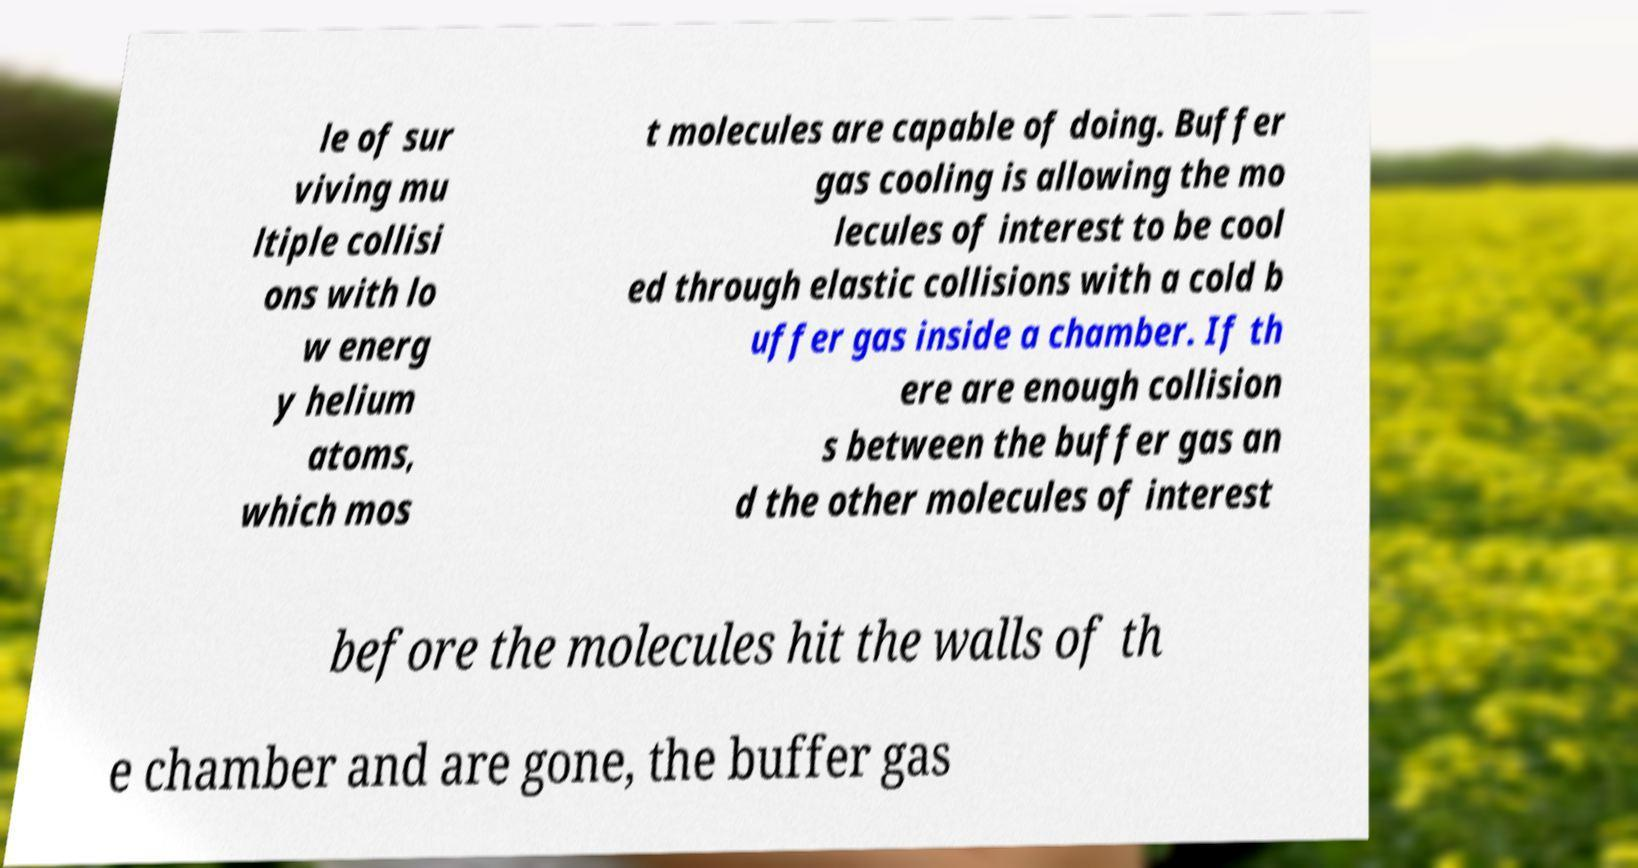Could you assist in decoding the text presented in this image and type it out clearly? le of sur viving mu ltiple collisi ons with lo w energ y helium atoms, which mos t molecules are capable of doing. Buffer gas cooling is allowing the mo lecules of interest to be cool ed through elastic collisions with a cold b uffer gas inside a chamber. If th ere are enough collision s between the buffer gas an d the other molecules of interest before the molecules hit the walls of th e chamber and are gone, the buffer gas 